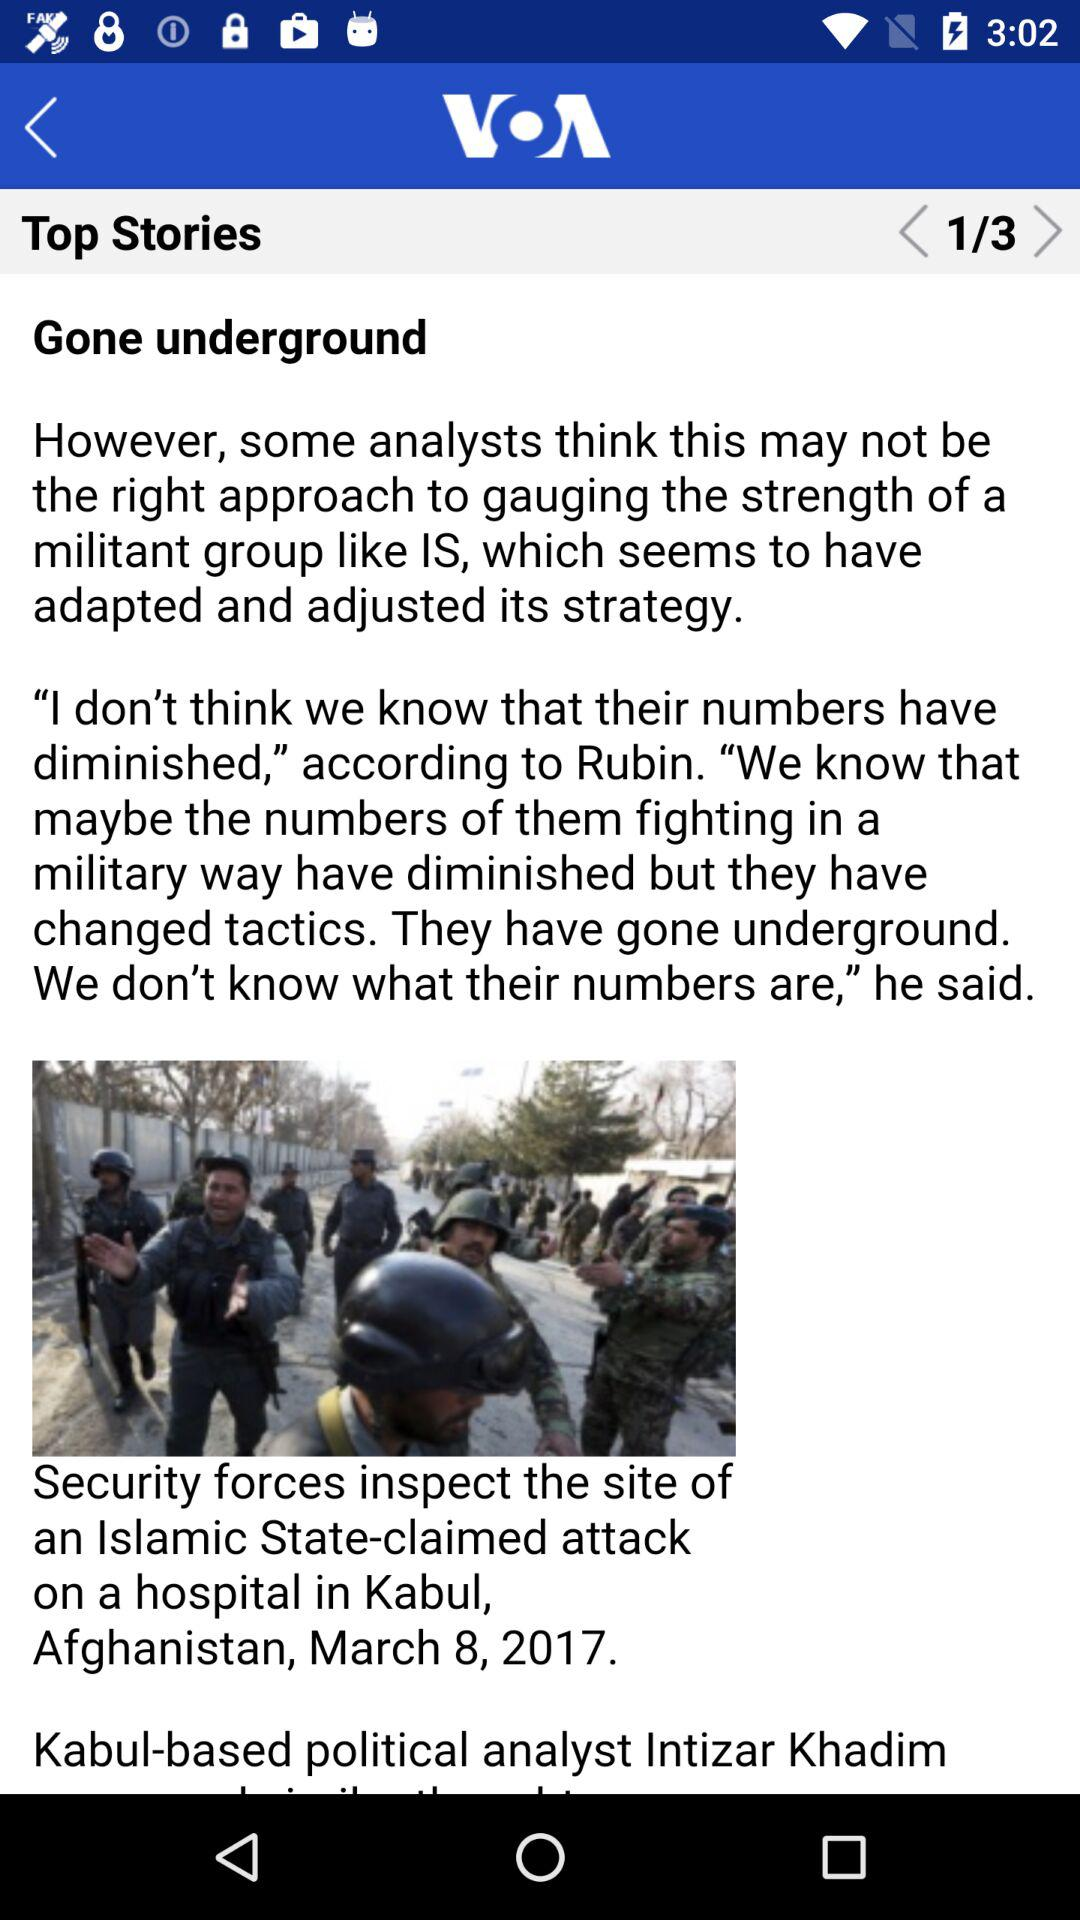What is the total number of stories? The total number of stories is 3. 